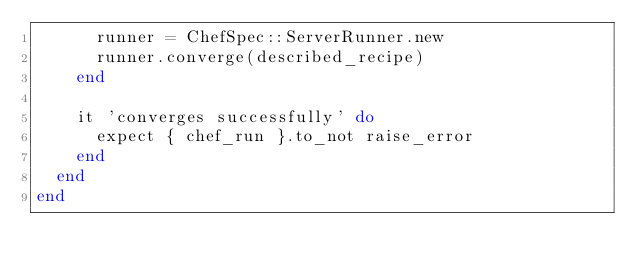<code> <loc_0><loc_0><loc_500><loc_500><_Ruby_>      runner = ChefSpec::ServerRunner.new
      runner.converge(described_recipe)
    end

    it 'converges successfully' do
      expect { chef_run }.to_not raise_error
    end
  end
end
</code> 